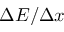Convert formula to latex. <formula><loc_0><loc_0><loc_500><loc_500>\Delta E / \Delta x</formula> 